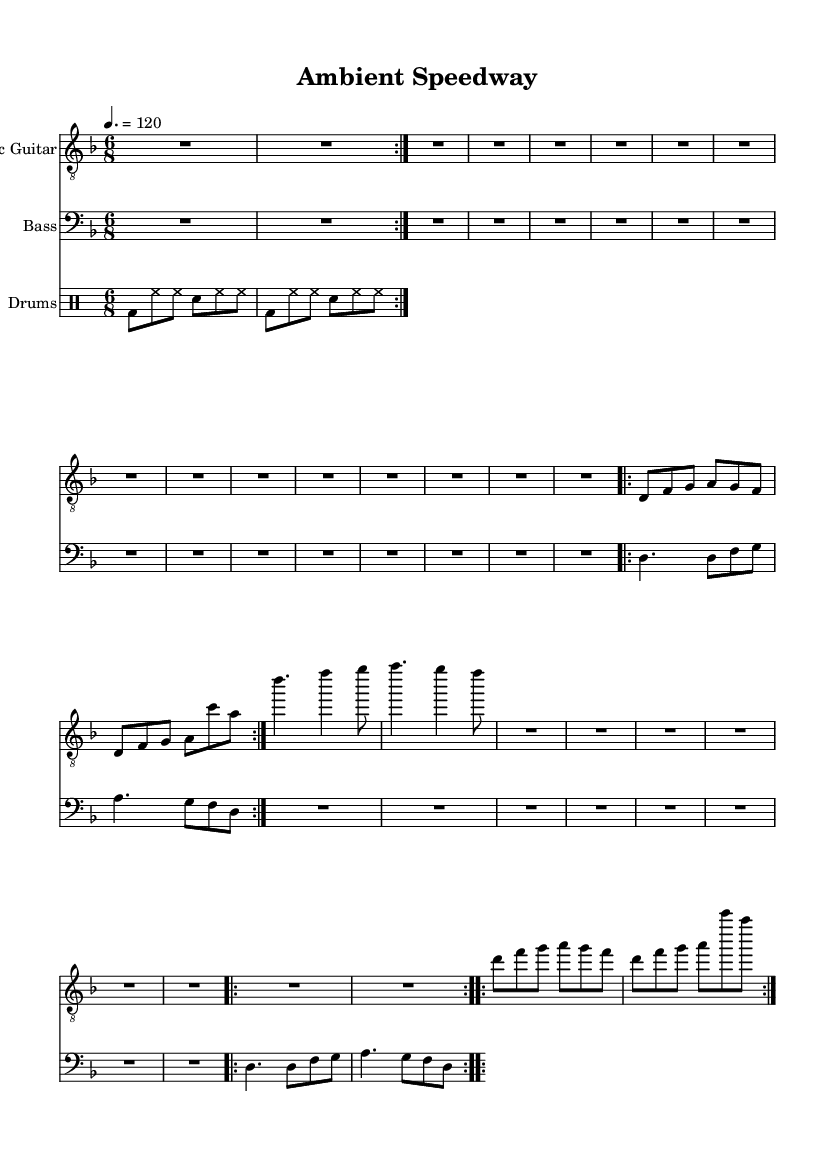What is the key signature of this music? The key signature is indicated at the beginning of the sheet music, showing one flat (B♭) which corresponds to D minor.
Answer: D minor What is the time signature of this piece? The time signature is located at the beginning of the sheet music, showing a six over eight designation (6/8). This means there are six eighth notes in each measure.
Answer: 6/8 What is the tempo marking for the piece? The tempo marking is specified in the sheet music, indicating how fast the piece should be played. In this case, it states "4. = 120," meaning the quarter note is equal to 120 beats per minute.
Answer: 120 What is the main key structure during the verses? The verse riff shows a repeating melodic structure centered primarily around the notes D, F, G, A, indicating a modal or diatonic approach. The foundational melody revolves around these notes, establishing the piece's character.
Answer: D, F, G, A How many measures are in the chorus section? To determine the number of measures, we can look at the chorus notation. The chorus consists of two lines of music, each with 4 measures based on the rhythm and note placements. Counting these, we find a total of 4 measures.
Answer: 4 What rhythmic pattern is characteristic of the drum part? The drum pattern exhibits a consistent groove with a bass drum (bd), hi-hat (hh), and snare (sn) playing interspersed eighth notes. Specifically, it alternates between bass and snare, creating a driving force typical in metal music.
Answer: 6/8 groove What are the dynamics indicated for the intro section? The intro section does not have specific dynamics written in the score but it generally starts with a rest, functioning as a buildup before the first melodic appearance. The initial silence serves to enhance the impact of the first played notes.
Answer: Rests 